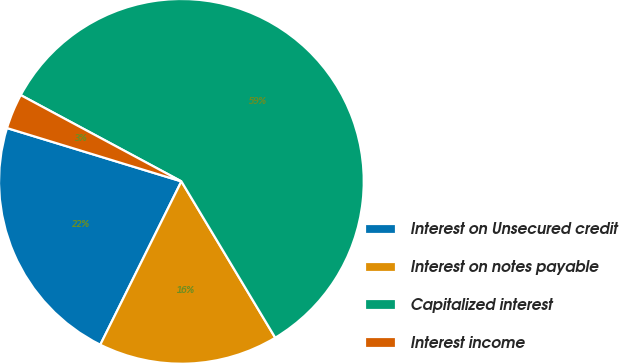Convert chart to OTSL. <chart><loc_0><loc_0><loc_500><loc_500><pie_chart><fcel>Interest on Unsecured credit<fcel>Interest on notes payable<fcel>Capitalized interest<fcel>Interest income<nl><fcel>22.39%<fcel>15.94%<fcel>58.56%<fcel>3.12%<nl></chart> 